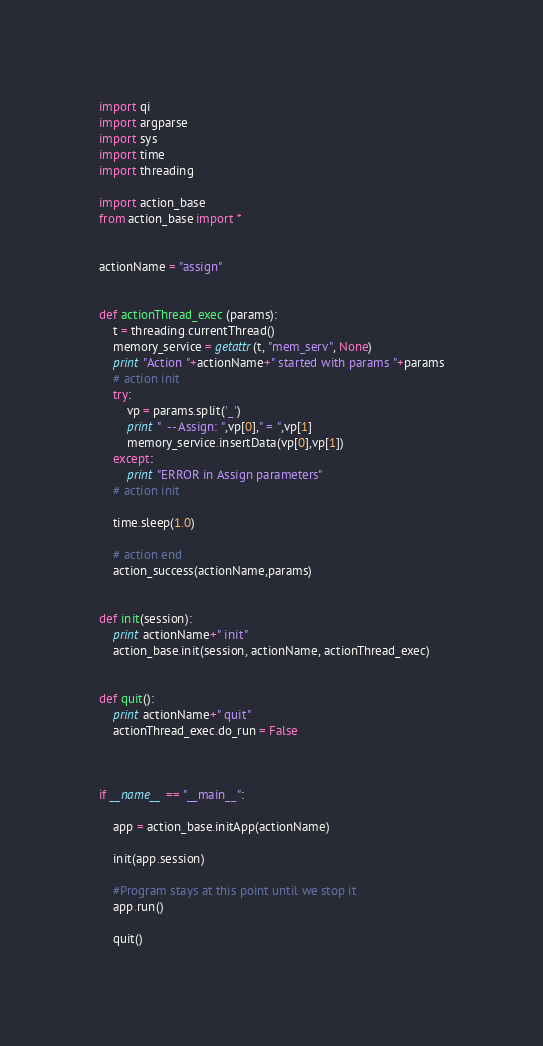<code> <loc_0><loc_0><loc_500><loc_500><_Python_>import qi
import argparse
import sys
import time
import threading

import action_base
from action_base import *


actionName = "assign"


def actionThread_exec (params):
    t = threading.currentThread()
    memory_service = getattr(t, "mem_serv", None)
    print "Action "+actionName+" started with params "+params
    # action init
    try:
        vp = params.split('_')
        print "  -- Assign: ",vp[0]," = ",vp[1]
        memory_service.insertData(vp[0],vp[1])
    except:
        print "ERROR in Assign parameters"
    # action init

    time.sleep(1.0)
		
    # action end
    action_success(actionName,params)


def init(session):
    print actionName+" init"
    action_base.init(session, actionName, actionThread_exec)


def quit():
    print actionName+" quit"
    actionThread_exec.do_run = False
    


if __name__ == "__main__":

    app = action_base.initApp(actionName)
    	
    init(app.session)

    #Program stays at this point until we stop it
    app.run()

    quit()


</code> 